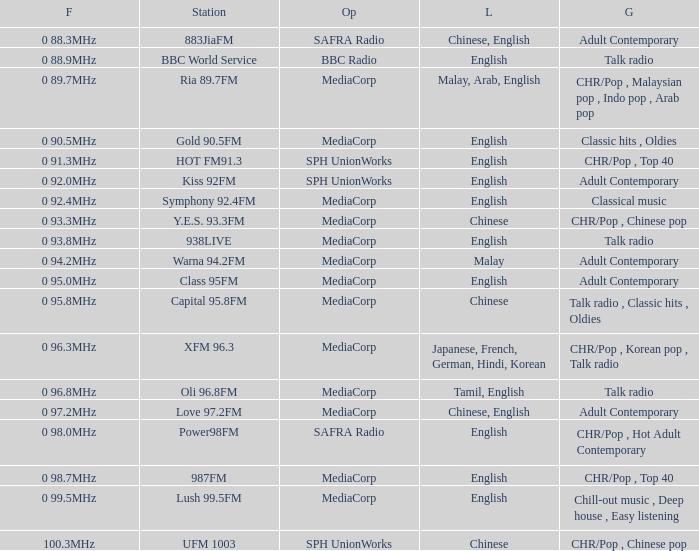Can you parse all the data within this table? {'header': ['F', 'Station', 'Op', 'L', 'G'], 'rows': [['0 88.3MHz', '883JiaFM', 'SAFRA Radio', 'Chinese, English', 'Adult Contemporary'], ['0 88.9MHz', 'BBC World Service', 'BBC Radio', 'English', 'Talk radio'], ['0 89.7MHz', 'Ria 89.7FM', 'MediaCorp', 'Malay, Arab, English', 'CHR/Pop , Malaysian pop , Indo pop , Arab pop'], ['0 90.5MHz', 'Gold 90.5FM', 'MediaCorp', 'English', 'Classic hits , Oldies'], ['0 91.3MHz', 'HOT FM91.3', 'SPH UnionWorks', 'English', 'CHR/Pop , Top 40'], ['0 92.0MHz', 'Kiss 92FM', 'SPH UnionWorks', 'English', 'Adult Contemporary'], ['0 92.4MHz', 'Symphony 92.4FM', 'MediaCorp', 'English', 'Classical music'], ['0 93.3MHz', 'Y.E.S. 93.3FM', 'MediaCorp', 'Chinese', 'CHR/Pop , Chinese pop'], ['0 93.8MHz', '938LIVE', 'MediaCorp', 'English', 'Talk radio'], ['0 94.2MHz', 'Warna 94.2FM', 'MediaCorp', 'Malay', 'Adult Contemporary'], ['0 95.0MHz', 'Class 95FM', 'MediaCorp', 'English', 'Adult Contemporary'], ['0 95.8MHz', 'Capital 95.8FM', 'MediaCorp', 'Chinese', 'Talk radio , Classic hits , Oldies'], ['0 96.3MHz', 'XFM 96.3', 'MediaCorp', 'Japanese, French, German, Hindi, Korean', 'CHR/Pop , Korean pop , Talk radio'], ['0 96.8MHz', 'Oli 96.8FM', 'MediaCorp', 'Tamil, English', 'Talk radio'], ['0 97.2MHz', 'Love 97.2FM', 'MediaCorp', 'Chinese, English', 'Adult Contemporary'], ['0 98.0MHz', 'Power98FM', 'SAFRA Radio', 'English', 'CHR/Pop , Hot Adult Contemporary'], ['0 98.7MHz', '987FM', 'MediaCorp', 'English', 'CHR/Pop , Top 40'], ['0 99.5MHz', 'Lush 99.5FM', 'MediaCorp', 'English', 'Chill-out music , Deep house , Easy listening'], ['100.3MHz', 'UFM 1003', 'SPH UnionWorks', 'Chinese', 'CHR/Pop , Chinese pop']]} Which genre is associated with the bbc world service? Talk radio. 